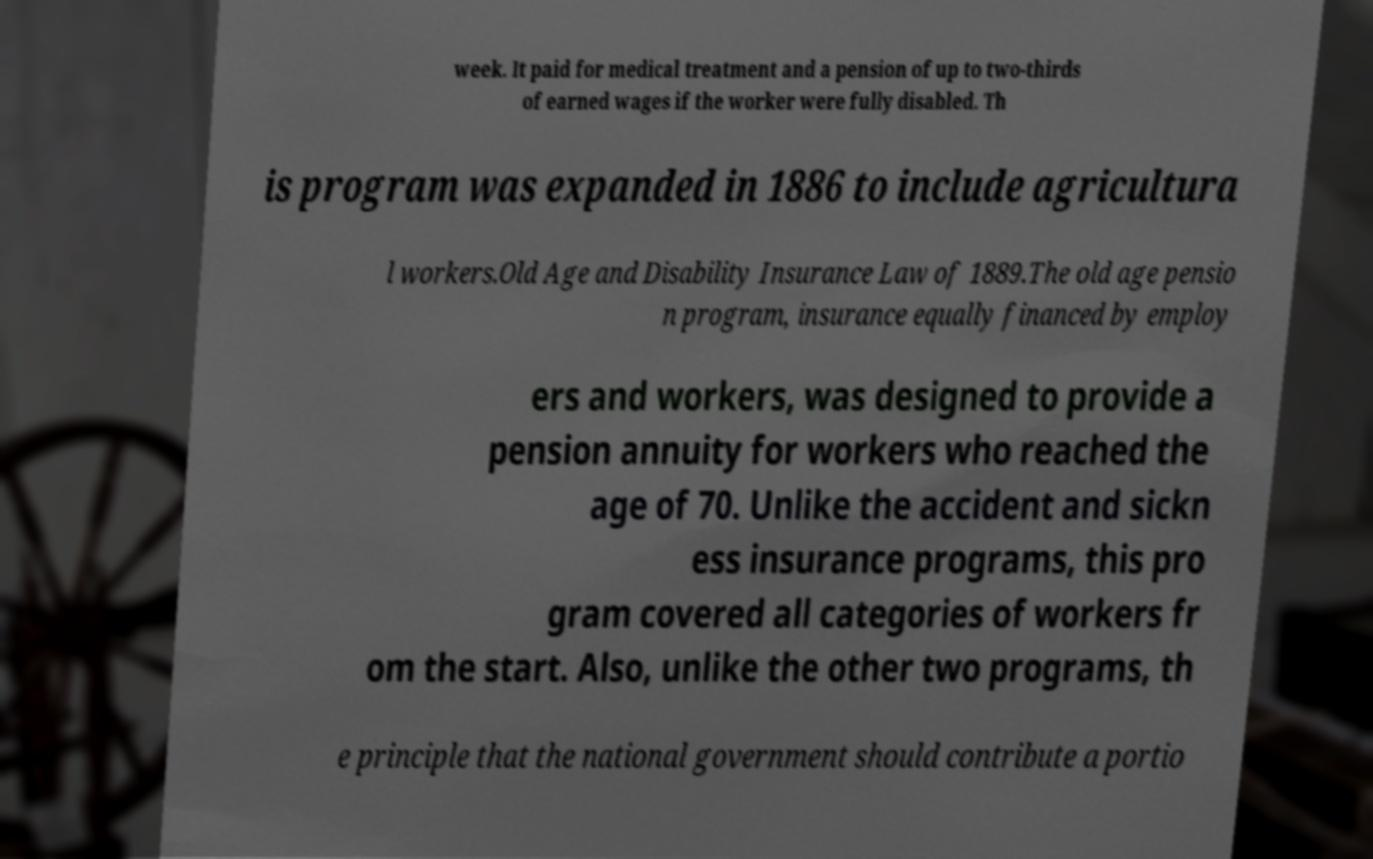I need the written content from this picture converted into text. Can you do that? week. It paid for medical treatment and a pension of up to two-thirds of earned wages if the worker were fully disabled. Th is program was expanded in 1886 to include agricultura l workers.Old Age and Disability Insurance Law of 1889.The old age pensio n program, insurance equally financed by employ ers and workers, was designed to provide a pension annuity for workers who reached the age of 70. Unlike the accident and sickn ess insurance programs, this pro gram covered all categories of workers fr om the start. Also, unlike the other two programs, th e principle that the national government should contribute a portio 